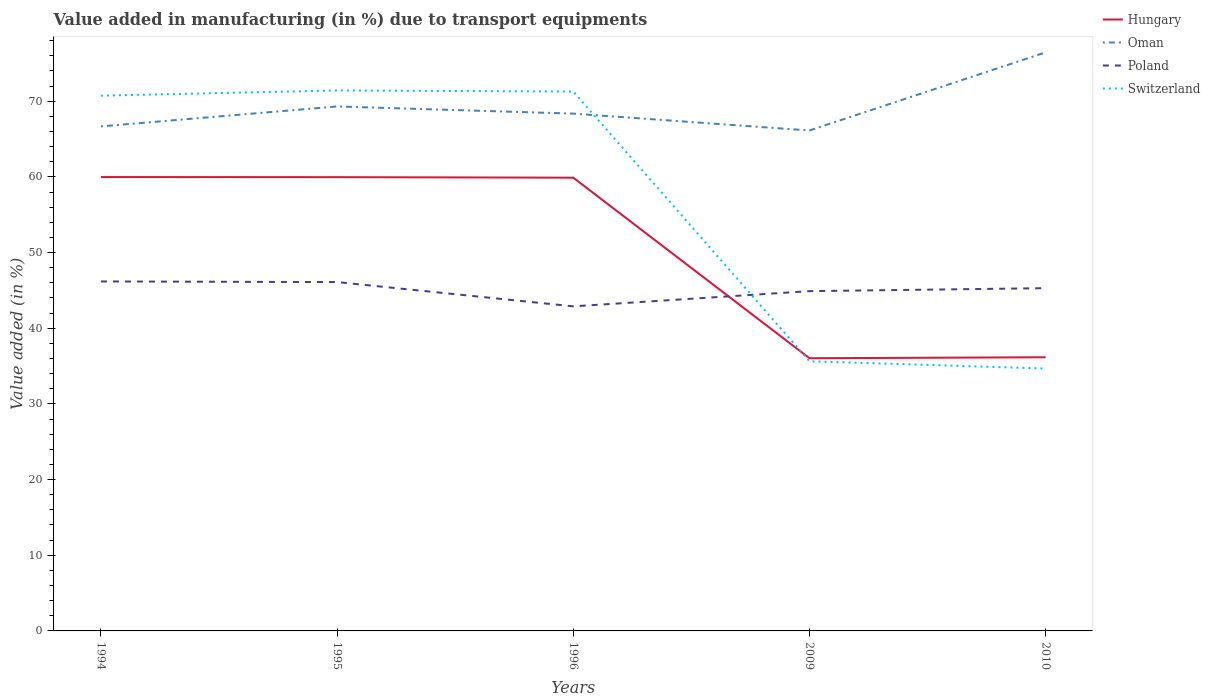Does the line corresponding to Poland intersect with the line corresponding to Oman?
Give a very brief answer. No. Across all years, what is the maximum percentage of value added in manufacturing due to transport equipments in Hungary?
Your response must be concise. 36.04. In which year was the percentage of value added in manufacturing due to transport equipments in Oman maximum?
Keep it short and to the point. 2009. What is the total percentage of value added in manufacturing due to transport equipments in Hungary in the graph?
Offer a terse response. 23.94. What is the difference between the highest and the second highest percentage of value added in manufacturing due to transport equipments in Hungary?
Your answer should be very brief. 23.94. How many lines are there?
Your answer should be compact. 4. What is the difference between two consecutive major ticks on the Y-axis?
Keep it short and to the point. 10. Are the values on the major ticks of Y-axis written in scientific E-notation?
Provide a succinct answer. No. Does the graph contain any zero values?
Give a very brief answer. No. Where does the legend appear in the graph?
Your answer should be compact. Top right. How many legend labels are there?
Give a very brief answer. 4. How are the legend labels stacked?
Keep it short and to the point. Vertical. What is the title of the graph?
Provide a succinct answer. Value added in manufacturing (in %) due to transport equipments. Does "Sri Lanka" appear as one of the legend labels in the graph?
Offer a very short reply. No. What is the label or title of the X-axis?
Ensure brevity in your answer.  Years. What is the label or title of the Y-axis?
Ensure brevity in your answer.  Value added (in %). What is the Value added (in %) in Hungary in 1994?
Your answer should be very brief. 59.98. What is the Value added (in %) in Oman in 1994?
Provide a short and direct response. 66.68. What is the Value added (in %) of Poland in 1994?
Make the answer very short. 46.18. What is the Value added (in %) of Switzerland in 1994?
Keep it short and to the point. 70.74. What is the Value added (in %) in Hungary in 1995?
Keep it short and to the point. 59.97. What is the Value added (in %) in Oman in 1995?
Offer a terse response. 69.31. What is the Value added (in %) of Poland in 1995?
Provide a short and direct response. 46.1. What is the Value added (in %) of Switzerland in 1995?
Your answer should be very brief. 71.42. What is the Value added (in %) in Hungary in 1996?
Provide a short and direct response. 59.9. What is the Value added (in %) of Oman in 1996?
Your response must be concise. 68.36. What is the Value added (in %) of Poland in 1996?
Offer a very short reply. 42.89. What is the Value added (in %) of Switzerland in 1996?
Offer a very short reply. 71.28. What is the Value added (in %) of Hungary in 2009?
Ensure brevity in your answer.  36.04. What is the Value added (in %) of Oman in 2009?
Your answer should be very brief. 66.13. What is the Value added (in %) of Poland in 2009?
Your response must be concise. 44.9. What is the Value added (in %) of Switzerland in 2009?
Offer a very short reply. 35.64. What is the Value added (in %) in Hungary in 2010?
Give a very brief answer. 36.16. What is the Value added (in %) of Oman in 2010?
Keep it short and to the point. 76.46. What is the Value added (in %) of Poland in 2010?
Provide a succinct answer. 45.3. What is the Value added (in %) in Switzerland in 2010?
Offer a very short reply. 34.68. Across all years, what is the maximum Value added (in %) of Hungary?
Offer a very short reply. 59.98. Across all years, what is the maximum Value added (in %) in Oman?
Provide a short and direct response. 76.46. Across all years, what is the maximum Value added (in %) in Poland?
Keep it short and to the point. 46.18. Across all years, what is the maximum Value added (in %) of Switzerland?
Provide a succinct answer. 71.42. Across all years, what is the minimum Value added (in %) in Hungary?
Offer a very short reply. 36.04. Across all years, what is the minimum Value added (in %) in Oman?
Provide a succinct answer. 66.13. Across all years, what is the minimum Value added (in %) of Poland?
Keep it short and to the point. 42.89. Across all years, what is the minimum Value added (in %) of Switzerland?
Offer a terse response. 34.68. What is the total Value added (in %) in Hungary in the graph?
Give a very brief answer. 252.05. What is the total Value added (in %) of Oman in the graph?
Offer a very short reply. 346.94. What is the total Value added (in %) of Poland in the graph?
Make the answer very short. 225.38. What is the total Value added (in %) in Switzerland in the graph?
Provide a short and direct response. 283.76. What is the difference between the Value added (in %) in Hungary in 1994 and that in 1995?
Your answer should be very brief. 0.01. What is the difference between the Value added (in %) of Oman in 1994 and that in 1995?
Make the answer very short. -2.63. What is the difference between the Value added (in %) of Poland in 1994 and that in 1995?
Keep it short and to the point. 0.08. What is the difference between the Value added (in %) in Switzerland in 1994 and that in 1995?
Keep it short and to the point. -0.69. What is the difference between the Value added (in %) in Hungary in 1994 and that in 1996?
Ensure brevity in your answer.  0.08. What is the difference between the Value added (in %) of Oman in 1994 and that in 1996?
Your answer should be compact. -1.69. What is the difference between the Value added (in %) in Poland in 1994 and that in 1996?
Your answer should be very brief. 3.29. What is the difference between the Value added (in %) of Switzerland in 1994 and that in 1996?
Your answer should be compact. -0.55. What is the difference between the Value added (in %) in Hungary in 1994 and that in 2009?
Ensure brevity in your answer.  23.94. What is the difference between the Value added (in %) of Oman in 1994 and that in 2009?
Offer a very short reply. 0.54. What is the difference between the Value added (in %) of Poland in 1994 and that in 2009?
Provide a succinct answer. 1.28. What is the difference between the Value added (in %) of Switzerland in 1994 and that in 2009?
Your answer should be compact. 35.1. What is the difference between the Value added (in %) in Hungary in 1994 and that in 2010?
Offer a terse response. 23.82. What is the difference between the Value added (in %) of Oman in 1994 and that in 2010?
Provide a succinct answer. -9.78. What is the difference between the Value added (in %) in Poland in 1994 and that in 2010?
Ensure brevity in your answer.  0.89. What is the difference between the Value added (in %) in Switzerland in 1994 and that in 2010?
Your answer should be very brief. 36.06. What is the difference between the Value added (in %) in Hungary in 1995 and that in 1996?
Provide a succinct answer. 0.07. What is the difference between the Value added (in %) of Oman in 1995 and that in 1996?
Keep it short and to the point. 0.95. What is the difference between the Value added (in %) of Poland in 1995 and that in 1996?
Provide a succinct answer. 3.21. What is the difference between the Value added (in %) of Switzerland in 1995 and that in 1996?
Offer a very short reply. 0.14. What is the difference between the Value added (in %) of Hungary in 1995 and that in 2009?
Offer a very short reply. 23.93. What is the difference between the Value added (in %) in Oman in 1995 and that in 2009?
Your response must be concise. 3.18. What is the difference between the Value added (in %) of Poland in 1995 and that in 2009?
Give a very brief answer. 1.2. What is the difference between the Value added (in %) of Switzerland in 1995 and that in 2009?
Provide a short and direct response. 35.79. What is the difference between the Value added (in %) in Hungary in 1995 and that in 2010?
Offer a very short reply. 23.8. What is the difference between the Value added (in %) in Oman in 1995 and that in 2010?
Provide a succinct answer. -7.15. What is the difference between the Value added (in %) of Poland in 1995 and that in 2010?
Your answer should be very brief. 0.81. What is the difference between the Value added (in %) in Switzerland in 1995 and that in 2010?
Offer a very short reply. 36.75. What is the difference between the Value added (in %) of Hungary in 1996 and that in 2009?
Give a very brief answer. 23.86. What is the difference between the Value added (in %) of Oman in 1996 and that in 2009?
Offer a very short reply. 2.23. What is the difference between the Value added (in %) of Poland in 1996 and that in 2009?
Offer a very short reply. -2.01. What is the difference between the Value added (in %) of Switzerland in 1996 and that in 2009?
Give a very brief answer. 35.65. What is the difference between the Value added (in %) in Hungary in 1996 and that in 2010?
Your answer should be very brief. 23.73. What is the difference between the Value added (in %) in Oman in 1996 and that in 2010?
Provide a short and direct response. -8.09. What is the difference between the Value added (in %) in Poland in 1996 and that in 2010?
Ensure brevity in your answer.  -2.4. What is the difference between the Value added (in %) of Switzerland in 1996 and that in 2010?
Your answer should be very brief. 36.61. What is the difference between the Value added (in %) of Hungary in 2009 and that in 2010?
Ensure brevity in your answer.  -0.13. What is the difference between the Value added (in %) of Oman in 2009 and that in 2010?
Your response must be concise. -10.32. What is the difference between the Value added (in %) of Poland in 2009 and that in 2010?
Give a very brief answer. -0.39. What is the difference between the Value added (in %) of Switzerland in 2009 and that in 2010?
Make the answer very short. 0.96. What is the difference between the Value added (in %) of Hungary in 1994 and the Value added (in %) of Oman in 1995?
Your answer should be compact. -9.33. What is the difference between the Value added (in %) of Hungary in 1994 and the Value added (in %) of Poland in 1995?
Give a very brief answer. 13.88. What is the difference between the Value added (in %) in Hungary in 1994 and the Value added (in %) in Switzerland in 1995?
Provide a short and direct response. -11.44. What is the difference between the Value added (in %) in Oman in 1994 and the Value added (in %) in Poland in 1995?
Ensure brevity in your answer.  20.57. What is the difference between the Value added (in %) in Oman in 1994 and the Value added (in %) in Switzerland in 1995?
Provide a short and direct response. -4.75. What is the difference between the Value added (in %) in Poland in 1994 and the Value added (in %) in Switzerland in 1995?
Provide a succinct answer. -25.24. What is the difference between the Value added (in %) in Hungary in 1994 and the Value added (in %) in Oman in 1996?
Offer a very short reply. -8.38. What is the difference between the Value added (in %) of Hungary in 1994 and the Value added (in %) of Poland in 1996?
Keep it short and to the point. 17.09. What is the difference between the Value added (in %) in Hungary in 1994 and the Value added (in %) in Switzerland in 1996?
Ensure brevity in your answer.  -11.3. What is the difference between the Value added (in %) in Oman in 1994 and the Value added (in %) in Poland in 1996?
Offer a very short reply. 23.78. What is the difference between the Value added (in %) in Oman in 1994 and the Value added (in %) in Switzerland in 1996?
Your answer should be compact. -4.61. What is the difference between the Value added (in %) in Poland in 1994 and the Value added (in %) in Switzerland in 1996?
Ensure brevity in your answer.  -25.1. What is the difference between the Value added (in %) of Hungary in 1994 and the Value added (in %) of Oman in 2009?
Provide a succinct answer. -6.15. What is the difference between the Value added (in %) in Hungary in 1994 and the Value added (in %) in Poland in 2009?
Ensure brevity in your answer.  15.08. What is the difference between the Value added (in %) in Hungary in 1994 and the Value added (in %) in Switzerland in 2009?
Keep it short and to the point. 24.34. What is the difference between the Value added (in %) in Oman in 1994 and the Value added (in %) in Poland in 2009?
Your answer should be compact. 21.77. What is the difference between the Value added (in %) in Oman in 1994 and the Value added (in %) in Switzerland in 2009?
Your answer should be compact. 31.04. What is the difference between the Value added (in %) in Poland in 1994 and the Value added (in %) in Switzerland in 2009?
Offer a very short reply. 10.55. What is the difference between the Value added (in %) in Hungary in 1994 and the Value added (in %) in Oman in 2010?
Ensure brevity in your answer.  -16.48. What is the difference between the Value added (in %) in Hungary in 1994 and the Value added (in %) in Poland in 2010?
Keep it short and to the point. 14.68. What is the difference between the Value added (in %) in Hungary in 1994 and the Value added (in %) in Switzerland in 2010?
Give a very brief answer. 25.3. What is the difference between the Value added (in %) in Oman in 1994 and the Value added (in %) in Poland in 2010?
Your response must be concise. 21.38. What is the difference between the Value added (in %) of Oman in 1994 and the Value added (in %) of Switzerland in 2010?
Your response must be concise. 32. What is the difference between the Value added (in %) of Poland in 1994 and the Value added (in %) of Switzerland in 2010?
Ensure brevity in your answer.  11.51. What is the difference between the Value added (in %) in Hungary in 1995 and the Value added (in %) in Oman in 1996?
Provide a short and direct response. -8.4. What is the difference between the Value added (in %) of Hungary in 1995 and the Value added (in %) of Poland in 1996?
Offer a terse response. 17.07. What is the difference between the Value added (in %) in Hungary in 1995 and the Value added (in %) in Switzerland in 1996?
Your answer should be compact. -11.32. What is the difference between the Value added (in %) in Oman in 1995 and the Value added (in %) in Poland in 1996?
Offer a very short reply. 26.42. What is the difference between the Value added (in %) in Oman in 1995 and the Value added (in %) in Switzerland in 1996?
Your answer should be compact. -1.97. What is the difference between the Value added (in %) of Poland in 1995 and the Value added (in %) of Switzerland in 1996?
Make the answer very short. -25.18. What is the difference between the Value added (in %) in Hungary in 1995 and the Value added (in %) in Oman in 2009?
Offer a very short reply. -6.17. What is the difference between the Value added (in %) of Hungary in 1995 and the Value added (in %) of Poland in 2009?
Ensure brevity in your answer.  15.06. What is the difference between the Value added (in %) in Hungary in 1995 and the Value added (in %) in Switzerland in 2009?
Your answer should be very brief. 24.33. What is the difference between the Value added (in %) in Oman in 1995 and the Value added (in %) in Poland in 2009?
Offer a very short reply. 24.41. What is the difference between the Value added (in %) in Oman in 1995 and the Value added (in %) in Switzerland in 2009?
Offer a very short reply. 33.67. What is the difference between the Value added (in %) of Poland in 1995 and the Value added (in %) of Switzerland in 2009?
Your answer should be compact. 10.47. What is the difference between the Value added (in %) in Hungary in 1995 and the Value added (in %) in Oman in 2010?
Provide a succinct answer. -16.49. What is the difference between the Value added (in %) of Hungary in 1995 and the Value added (in %) of Poland in 2010?
Offer a terse response. 14.67. What is the difference between the Value added (in %) in Hungary in 1995 and the Value added (in %) in Switzerland in 2010?
Your response must be concise. 25.29. What is the difference between the Value added (in %) in Oman in 1995 and the Value added (in %) in Poland in 2010?
Keep it short and to the point. 24.01. What is the difference between the Value added (in %) in Oman in 1995 and the Value added (in %) in Switzerland in 2010?
Keep it short and to the point. 34.63. What is the difference between the Value added (in %) of Poland in 1995 and the Value added (in %) of Switzerland in 2010?
Your answer should be compact. 11.43. What is the difference between the Value added (in %) of Hungary in 1996 and the Value added (in %) of Oman in 2009?
Ensure brevity in your answer.  -6.24. What is the difference between the Value added (in %) in Hungary in 1996 and the Value added (in %) in Poland in 2009?
Ensure brevity in your answer.  14.99. What is the difference between the Value added (in %) of Hungary in 1996 and the Value added (in %) of Switzerland in 2009?
Make the answer very short. 24.26. What is the difference between the Value added (in %) in Oman in 1996 and the Value added (in %) in Poland in 2009?
Keep it short and to the point. 23.46. What is the difference between the Value added (in %) in Oman in 1996 and the Value added (in %) in Switzerland in 2009?
Offer a very short reply. 32.73. What is the difference between the Value added (in %) in Poland in 1996 and the Value added (in %) in Switzerland in 2009?
Your answer should be compact. 7.26. What is the difference between the Value added (in %) of Hungary in 1996 and the Value added (in %) of Oman in 2010?
Offer a terse response. -16.56. What is the difference between the Value added (in %) in Hungary in 1996 and the Value added (in %) in Poland in 2010?
Give a very brief answer. 14.6. What is the difference between the Value added (in %) in Hungary in 1996 and the Value added (in %) in Switzerland in 2010?
Provide a succinct answer. 25.22. What is the difference between the Value added (in %) of Oman in 1996 and the Value added (in %) of Poland in 2010?
Your response must be concise. 23.07. What is the difference between the Value added (in %) in Oman in 1996 and the Value added (in %) in Switzerland in 2010?
Offer a terse response. 33.69. What is the difference between the Value added (in %) of Poland in 1996 and the Value added (in %) of Switzerland in 2010?
Keep it short and to the point. 8.22. What is the difference between the Value added (in %) in Hungary in 2009 and the Value added (in %) in Oman in 2010?
Provide a short and direct response. -40.42. What is the difference between the Value added (in %) of Hungary in 2009 and the Value added (in %) of Poland in 2010?
Offer a very short reply. -9.26. What is the difference between the Value added (in %) in Hungary in 2009 and the Value added (in %) in Switzerland in 2010?
Ensure brevity in your answer.  1.36. What is the difference between the Value added (in %) of Oman in 2009 and the Value added (in %) of Poland in 2010?
Your answer should be very brief. 20.84. What is the difference between the Value added (in %) of Oman in 2009 and the Value added (in %) of Switzerland in 2010?
Ensure brevity in your answer.  31.46. What is the difference between the Value added (in %) of Poland in 2009 and the Value added (in %) of Switzerland in 2010?
Make the answer very short. 10.23. What is the average Value added (in %) of Hungary per year?
Provide a short and direct response. 50.41. What is the average Value added (in %) in Oman per year?
Offer a terse response. 69.39. What is the average Value added (in %) of Poland per year?
Your response must be concise. 45.08. What is the average Value added (in %) in Switzerland per year?
Provide a succinct answer. 56.75. In the year 1994, what is the difference between the Value added (in %) of Hungary and Value added (in %) of Oman?
Your response must be concise. -6.7. In the year 1994, what is the difference between the Value added (in %) in Hungary and Value added (in %) in Poland?
Give a very brief answer. 13.8. In the year 1994, what is the difference between the Value added (in %) of Hungary and Value added (in %) of Switzerland?
Your answer should be compact. -10.76. In the year 1994, what is the difference between the Value added (in %) in Oman and Value added (in %) in Poland?
Your answer should be very brief. 20.49. In the year 1994, what is the difference between the Value added (in %) in Oman and Value added (in %) in Switzerland?
Offer a terse response. -4.06. In the year 1994, what is the difference between the Value added (in %) of Poland and Value added (in %) of Switzerland?
Offer a very short reply. -24.55. In the year 1995, what is the difference between the Value added (in %) of Hungary and Value added (in %) of Oman?
Provide a succinct answer. -9.34. In the year 1995, what is the difference between the Value added (in %) of Hungary and Value added (in %) of Poland?
Make the answer very short. 13.86. In the year 1995, what is the difference between the Value added (in %) in Hungary and Value added (in %) in Switzerland?
Give a very brief answer. -11.46. In the year 1995, what is the difference between the Value added (in %) in Oman and Value added (in %) in Poland?
Give a very brief answer. 23.21. In the year 1995, what is the difference between the Value added (in %) in Oman and Value added (in %) in Switzerland?
Offer a terse response. -2.11. In the year 1995, what is the difference between the Value added (in %) of Poland and Value added (in %) of Switzerland?
Keep it short and to the point. -25.32. In the year 1996, what is the difference between the Value added (in %) of Hungary and Value added (in %) of Oman?
Offer a terse response. -8.47. In the year 1996, what is the difference between the Value added (in %) of Hungary and Value added (in %) of Poland?
Keep it short and to the point. 17. In the year 1996, what is the difference between the Value added (in %) of Hungary and Value added (in %) of Switzerland?
Offer a terse response. -11.39. In the year 1996, what is the difference between the Value added (in %) in Oman and Value added (in %) in Poland?
Your answer should be compact. 25.47. In the year 1996, what is the difference between the Value added (in %) of Oman and Value added (in %) of Switzerland?
Provide a succinct answer. -2.92. In the year 1996, what is the difference between the Value added (in %) of Poland and Value added (in %) of Switzerland?
Give a very brief answer. -28.39. In the year 2009, what is the difference between the Value added (in %) of Hungary and Value added (in %) of Oman?
Keep it short and to the point. -30.1. In the year 2009, what is the difference between the Value added (in %) of Hungary and Value added (in %) of Poland?
Your answer should be compact. -8.86. In the year 2009, what is the difference between the Value added (in %) of Hungary and Value added (in %) of Switzerland?
Offer a terse response. 0.4. In the year 2009, what is the difference between the Value added (in %) in Oman and Value added (in %) in Poland?
Your answer should be very brief. 21.23. In the year 2009, what is the difference between the Value added (in %) in Oman and Value added (in %) in Switzerland?
Your answer should be very brief. 30.5. In the year 2009, what is the difference between the Value added (in %) in Poland and Value added (in %) in Switzerland?
Your answer should be very brief. 9.27. In the year 2010, what is the difference between the Value added (in %) in Hungary and Value added (in %) in Oman?
Your answer should be very brief. -40.29. In the year 2010, what is the difference between the Value added (in %) of Hungary and Value added (in %) of Poland?
Provide a short and direct response. -9.13. In the year 2010, what is the difference between the Value added (in %) in Hungary and Value added (in %) in Switzerland?
Your answer should be very brief. 1.49. In the year 2010, what is the difference between the Value added (in %) of Oman and Value added (in %) of Poland?
Your answer should be compact. 31.16. In the year 2010, what is the difference between the Value added (in %) of Oman and Value added (in %) of Switzerland?
Provide a succinct answer. 41.78. In the year 2010, what is the difference between the Value added (in %) in Poland and Value added (in %) in Switzerland?
Your answer should be very brief. 10.62. What is the ratio of the Value added (in %) of Hungary in 1994 to that in 1995?
Provide a succinct answer. 1. What is the ratio of the Value added (in %) of Oman in 1994 to that in 1995?
Make the answer very short. 0.96. What is the ratio of the Value added (in %) in Oman in 1994 to that in 1996?
Give a very brief answer. 0.98. What is the ratio of the Value added (in %) in Poland in 1994 to that in 1996?
Your answer should be very brief. 1.08. What is the ratio of the Value added (in %) of Switzerland in 1994 to that in 1996?
Provide a short and direct response. 0.99. What is the ratio of the Value added (in %) of Hungary in 1994 to that in 2009?
Your answer should be very brief. 1.66. What is the ratio of the Value added (in %) of Oman in 1994 to that in 2009?
Ensure brevity in your answer.  1.01. What is the ratio of the Value added (in %) in Poland in 1994 to that in 2009?
Provide a short and direct response. 1.03. What is the ratio of the Value added (in %) in Switzerland in 1994 to that in 2009?
Offer a very short reply. 1.99. What is the ratio of the Value added (in %) in Hungary in 1994 to that in 2010?
Keep it short and to the point. 1.66. What is the ratio of the Value added (in %) of Oman in 1994 to that in 2010?
Provide a short and direct response. 0.87. What is the ratio of the Value added (in %) of Poland in 1994 to that in 2010?
Keep it short and to the point. 1.02. What is the ratio of the Value added (in %) in Switzerland in 1994 to that in 2010?
Your response must be concise. 2.04. What is the ratio of the Value added (in %) in Hungary in 1995 to that in 1996?
Give a very brief answer. 1. What is the ratio of the Value added (in %) in Oman in 1995 to that in 1996?
Offer a terse response. 1.01. What is the ratio of the Value added (in %) of Poland in 1995 to that in 1996?
Keep it short and to the point. 1.07. What is the ratio of the Value added (in %) in Switzerland in 1995 to that in 1996?
Provide a short and direct response. 1. What is the ratio of the Value added (in %) of Hungary in 1995 to that in 2009?
Keep it short and to the point. 1.66. What is the ratio of the Value added (in %) of Oman in 1995 to that in 2009?
Offer a very short reply. 1.05. What is the ratio of the Value added (in %) in Poland in 1995 to that in 2009?
Keep it short and to the point. 1.03. What is the ratio of the Value added (in %) in Switzerland in 1995 to that in 2009?
Ensure brevity in your answer.  2. What is the ratio of the Value added (in %) in Hungary in 1995 to that in 2010?
Your answer should be very brief. 1.66. What is the ratio of the Value added (in %) of Oman in 1995 to that in 2010?
Offer a very short reply. 0.91. What is the ratio of the Value added (in %) of Poland in 1995 to that in 2010?
Your response must be concise. 1.02. What is the ratio of the Value added (in %) of Switzerland in 1995 to that in 2010?
Give a very brief answer. 2.06. What is the ratio of the Value added (in %) in Hungary in 1996 to that in 2009?
Your response must be concise. 1.66. What is the ratio of the Value added (in %) in Oman in 1996 to that in 2009?
Make the answer very short. 1.03. What is the ratio of the Value added (in %) in Poland in 1996 to that in 2009?
Your answer should be compact. 0.96. What is the ratio of the Value added (in %) of Switzerland in 1996 to that in 2009?
Offer a terse response. 2. What is the ratio of the Value added (in %) of Hungary in 1996 to that in 2010?
Your answer should be compact. 1.66. What is the ratio of the Value added (in %) of Oman in 1996 to that in 2010?
Provide a short and direct response. 0.89. What is the ratio of the Value added (in %) of Poland in 1996 to that in 2010?
Ensure brevity in your answer.  0.95. What is the ratio of the Value added (in %) of Switzerland in 1996 to that in 2010?
Make the answer very short. 2.06. What is the ratio of the Value added (in %) in Hungary in 2009 to that in 2010?
Your answer should be very brief. 1. What is the ratio of the Value added (in %) of Oman in 2009 to that in 2010?
Your answer should be very brief. 0.86. What is the ratio of the Value added (in %) of Switzerland in 2009 to that in 2010?
Ensure brevity in your answer.  1.03. What is the difference between the highest and the second highest Value added (in %) in Hungary?
Give a very brief answer. 0.01. What is the difference between the highest and the second highest Value added (in %) of Oman?
Give a very brief answer. 7.15. What is the difference between the highest and the second highest Value added (in %) in Poland?
Ensure brevity in your answer.  0.08. What is the difference between the highest and the second highest Value added (in %) in Switzerland?
Keep it short and to the point. 0.14. What is the difference between the highest and the lowest Value added (in %) in Hungary?
Keep it short and to the point. 23.94. What is the difference between the highest and the lowest Value added (in %) in Oman?
Give a very brief answer. 10.32. What is the difference between the highest and the lowest Value added (in %) of Poland?
Make the answer very short. 3.29. What is the difference between the highest and the lowest Value added (in %) in Switzerland?
Provide a short and direct response. 36.75. 